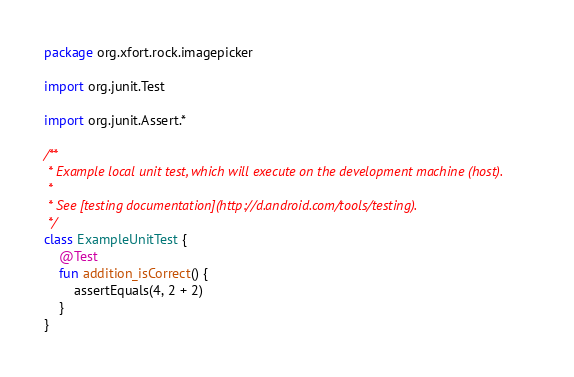<code> <loc_0><loc_0><loc_500><loc_500><_Kotlin_>package org.xfort.rock.imagepicker

import org.junit.Test

import org.junit.Assert.*

/**
 * Example local unit test, which will execute on the development machine (host).
 *
 * See [testing documentation](http://d.android.com/tools/testing).
 */
class ExampleUnitTest {
    @Test
    fun addition_isCorrect() {
        assertEquals(4, 2 + 2)
    }
}</code> 